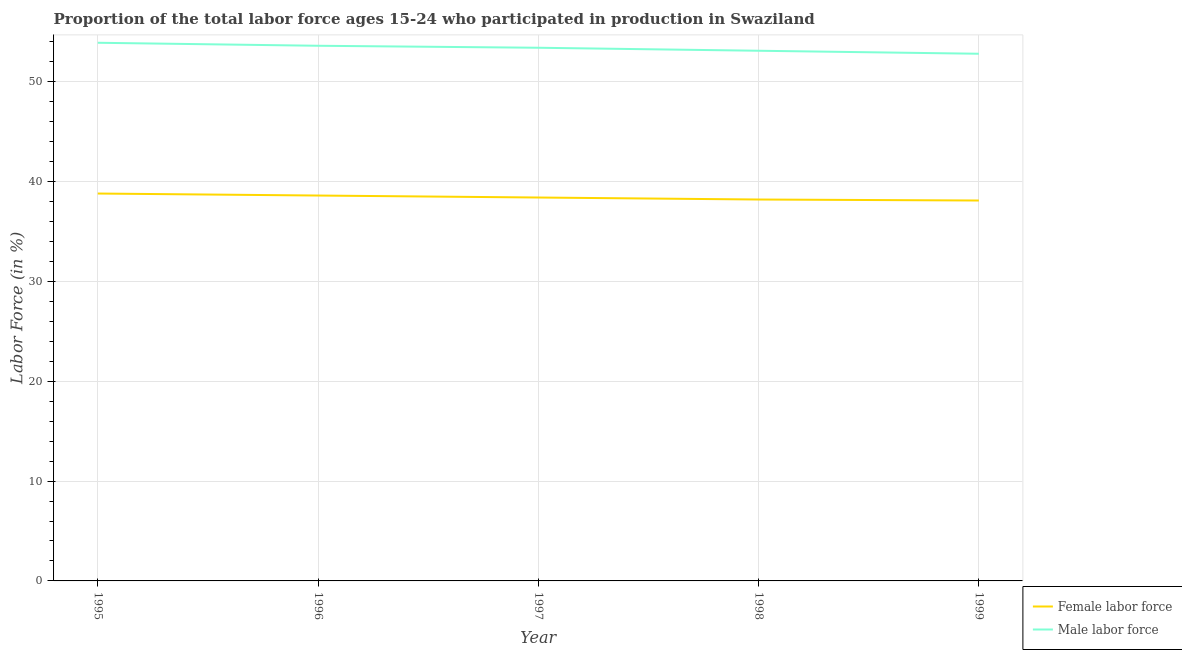What is the percentage of female labor force in 1995?
Your answer should be very brief. 38.8. Across all years, what is the maximum percentage of female labor force?
Give a very brief answer. 38.8. Across all years, what is the minimum percentage of female labor force?
Offer a terse response. 38.1. In which year was the percentage of male labour force minimum?
Make the answer very short. 1999. What is the total percentage of female labor force in the graph?
Your answer should be compact. 192.1. What is the difference between the percentage of male labour force in 1998 and that in 1999?
Your response must be concise. 0.3. What is the difference between the percentage of female labor force in 1998 and the percentage of male labour force in 1995?
Provide a succinct answer. -15.7. What is the average percentage of male labour force per year?
Provide a succinct answer. 53.36. In the year 1998, what is the difference between the percentage of female labor force and percentage of male labour force?
Give a very brief answer. -14.9. What is the ratio of the percentage of female labor force in 1997 to that in 1999?
Your answer should be compact. 1.01. What is the difference between the highest and the second highest percentage of female labor force?
Offer a terse response. 0.2. What is the difference between the highest and the lowest percentage of male labour force?
Your answer should be compact. 1.1. In how many years, is the percentage of male labour force greater than the average percentage of male labour force taken over all years?
Your response must be concise. 3. Is the percentage of male labour force strictly less than the percentage of female labor force over the years?
Give a very brief answer. No. Does the graph contain any zero values?
Offer a very short reply. No. Where does the legend appear in the graph?
Your response must be concise. Bottom right. How many legend labels are there?
Ensure brevity in your answer.  2. What is the title of the graph?
Ensure brevity in your answer.  Proportion of the total labor force ages 15-24 who participated in production in Swaziland. What is the label or title of the Y-axis?
Provide a short and direct response. Labor Force (in %). What is the Labor Force (in %) of Female labor force in 1995?
Keep it short and to the point. 38.8. What is the Labor Force (in %) of Male labor force in 1995?
Offer a very short reply. 53.9. What is the Labor Force (in %) in Female labor force in 1996?
Offer a terse response. 38.6. What is the Labor Force (in %) of Male labor force in 1996?
Your answer should be very brief. 53.6. What is the Labor Force (in %) of Female labor force in 1997?
Give a very brief answer. 38.4. What is the Labor Force (in %) in Male labor force in 1997?
Offer a terse response. 53.4. What is the Labor Force (in %) in Female labor force in 1998?
Provide a short and direct response. 38.2. What is the Labor Force (in %) in Male labor force in 1998?
Your response must be concise. 53.1. What is the Labor Force (in %) in Female labor force in 1999?
Your answer should be very brief. 38.1. What is the Labor Force (in %) of Male labor force in 1999?
Provide a succinct answer. 52.8. Across all years, what is the maximum Labor Force (in %) in Female labor force?
Offer a very short reply. 38.8. Across all years, what is the maximum Labor Force (in %) in Male labor force?
Offer a terse response. 53.9. Across all years, what is the minimum Labor Force (in %) in Female labor force?
Provide a short and direct response. 38.1. Across all years, what is the minimum Labor Force (in %) in Male labor force?
Your response must be concise. 52.8. What is the total Labor Force (in %) of Female labor force in the graph?
Provide a short and direct response. 192.1. What is the total Labor Force (in %) in Male labor force in the graph?
Provide a short and direct response. 266.8. What is the difference between the Labor Force (in %) of Female labor force in 1995 and that in 1997?
Give a very brief answer. 0.4. What is the difference between the Labor Force (in %) in Male labor force in 1995 and that in 1997?
Ensure brevity in your answer.  0.5. What is the difference between the Labor Force (in %) in Female labor force in 1996 and that in 1997?
Your answer should be very brief. 0.2. What is the difference between the Labor Force (in %) in Female labor force in 1997 and that in 1998?
Keep it short and to the point. 0.2. What is the difference between the Labor Force (in %) in Female labor force in 1997 and that in 1999?
Your response must be concise. 0.3. What is the difference between the Labor Force (in %) of Male labor force in 1997 and that in 1999?
Your answer should be very brief. 0.6. What is the difference between the Labor Force (in %) of Female labor force in 1998 and that in 1999?
Ensure brevity in your answer.  0.1. What is the difference between the Labor Force (in %) of Female labor force in 1995 and the Labor Force (in %) of Male labor force in 1996?
Make the answer very short. -14.8. What is the difference between the Labor Force (in %) of Female labor force in 1995 and the Labor Force (in %) of Male labor force in 1997?
Offer a terse response. -14.6. What is the difference between the Labor Force (in %) of Female labor force in 1995 and the Labor Force (in %) of Male labor force in 1998?
Provide a succinct answer. -14.3. What is the difference between the Labor Force (in %) of Female labor force in 1996 and the Labor Force (in %) of Male labor force in 1997?
Ensure brevity in your answer.  -14.8. What is the difference between the Labor Force (in %) of Female labor force in 1997 and the Labor Force (in %) of Male labor force in 1998?
Give a very brief answer. -14.7. What is the difference between the Labor Force (in %) in Female labor force in 1997 and the Labor Force (in %) in Male labor force in 1999?
Your answer should be very brief. -14.4. What is the difference between the Labor Force (in %) of Female labor force in 1998 and the Labor Force (in %) of Male labor force in 1999?
Offer a very short reply. -14.6. What is the average Labor Force (in %) in Female labor force per year?
Your answer should be compact. 38.42. What is the average Labor Force (in %) of Male labor force per year?
Your answer should be compact. 53.36. In the year 1995, what is the difference between the Labor Force (in %) in Female labor force and Labor Force (in %) in Male labor force?
Provide a succinct answer. -15.1. In the year 1996, what is the difference between the Labor Force (in %) in Female labor force and Labor Force (in %) in Male labor force?
Keep it short and to the point. -15. In the year 1997, what is the difference between the Labor Force (in %) of Female labor force and Labor Force (in %) of Male labor force?
Your response must be concise. -15. In the year 1998, what is the difference between the Labor Force (in %) of Female labor force and Labor Force (in %) of Male labor force?
Your response must be concise. -14.9. In the year 1999, what is the difference between the Labor Force (in %) of Female labor force and Labor Force (in %) of Male labor force?
Your answer should be very brief. -14.7. What is the ratio of the Labor Force (in %) of Male labor force in 1995 to that in 1996?
Your answer should be compact. 1.01. What is the ratio of the Labor Force (in %) in Female labor force in 1995 to that in 1997?
Your answer should be very brief. 1.01. What is the ratio of the Labor Force (in %) of Male labor force in 1995 to that in 1997?
Your answer should be very brief. 1.01. What is the ratio of the Labor Force (in %) of Female labor force in 1995 to that in 1998?
Offer a very short reply. 1.02. What is the ratio of the Labor Force (in %) in Male labor force in 1995 to that in 1998?
Provide a short and direct response. 1.02. What is the ratio of the Labor Force (in %) in Female labor force in 1995 to that in 1999?
Ensure brevity in your answer.  1.02. What is the ratio of the Labor Force (in %) in Male labor force in 1995 to that in 1999?
Provide a succinct answer. 1.02. What is the ratio of the Labor Force (in %) in Female labor force in 1996 to that in 1998?
Give a very brief answer. 1.01. What is the ratio of the Labor Force (in %) in Male labor force in 1996 to that in 1998?
Offer a very short reply. 1.01. What is the ratio of the Labor Force (in %) in Female labor force in 1996 to that in 1999?
Ensure brevity in your answer.  1.01. What is the ratio of the Labor Force (in %) in Male labor force in 1996 to that in 1999?
Provide a succinct answer. 1.02. What is the ratio of the Labor Force (in %) in Female labor force in 1997 to that in 1998?
Provide a short and direct response. 1.01. What is the ratio of the Labor Force (in %) of Male labor force in 1997 to that in 1998?
Offer a terse response. 1.01. What is the ratio of the Labor Force (in %) of Female labor force in 1997 to that in 1999?
Provide a succinct answer. 1.01. What is the ratio of the Labor Force (in %) of Male labor force in 1997 to that in 1999?
Your response must be concise. 1.01. What is the ratio of the Labor Force (in %) in Male labor force in 1998 to that in 1999?
Your answer should be compact. 1.01. What is the difference between the highest and the second highest Labor Force (in %) in Male labor force?
Offer a very short reply. 0.3. What is the difference between the highest and the lowest Labor Force (in %) of Male labor force?
Your response must be concise. 1.1. 